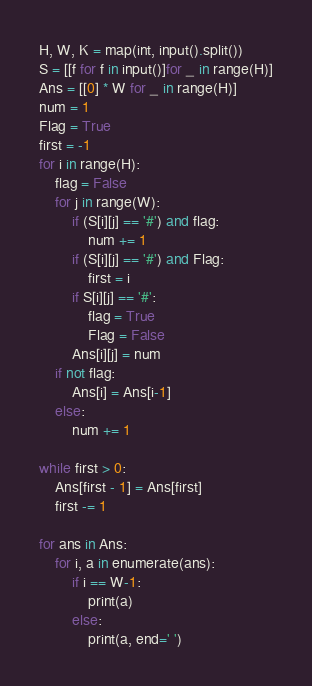Convert code to text. <code><loc_0><loc_0><loc_500><loc_500><_Python_>H, W, K = map(int, input().split())
S = [[f for f in input()]for _ in range(H)]
Ans = [[0] * W for _ in range(H)]
num = 1
Flag = True
first = -1
for i in range(H):
    flag = False
    for j in range(W):
        if (S[i][j] == '#') and flag:
            num += 1
        if (S[i][j] == '#') and Flag:
            first = i
        if S[i][j] == '#':
            flag = True
            Flag = False
        Ans[i][j] = num
    if not flag:
        Ans[i] = Ans[i-1]
    else:
        num += 1

while first > 0:
    Ans[first - 1] = Ans[first]
    first -= 1

for ans in Ans:
    for i, a in enumerate(ans):
        if i == W-1:
            print(a)
        else:
            print(a, end=' ')






</code> 